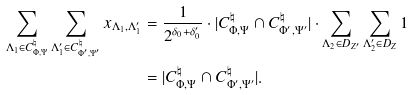<formula> <loc_0><loc_0><loc_500><loc_500>\sum _ { \Lambda _ { 1 } \in C ^ { \natural } _ { \Phi , \Psi } } \sum _ { \Lambda ^ { \prime } _ { 1 } \in C ^ { \natural } _ { \Phi ^ { \prime } , \Psi ^ { \prime } } } x _ { \Lambda _ { 1 } , \Lambda ^ { \prime } _ { 1 } } & = \frac { 1 } { 2 ^ { \delta _ { 0 } + \delta _ { 0 } ^ { \prime } } } \cdot | C ^ { \natural } _ { \Phi , \Psi } \cap C ^ { \natural } _ { \Phi ^ { \prime } , \Psi ^ { \prime } } | \cdot \sum _ { \Lambda _ { 2 } \in D _ { Z ^ { \prime } } } \sum _ { \Lambda _ { 2 } ^ { \prime } \in D _ { Z } } 1 \\ & = | C ^ { \natural } _ { \Phi , \Psi } \cap C ^ { \natural } _ { \Phi ^ { \prime } , \Psi ^ { \prime } } | .</formula> 